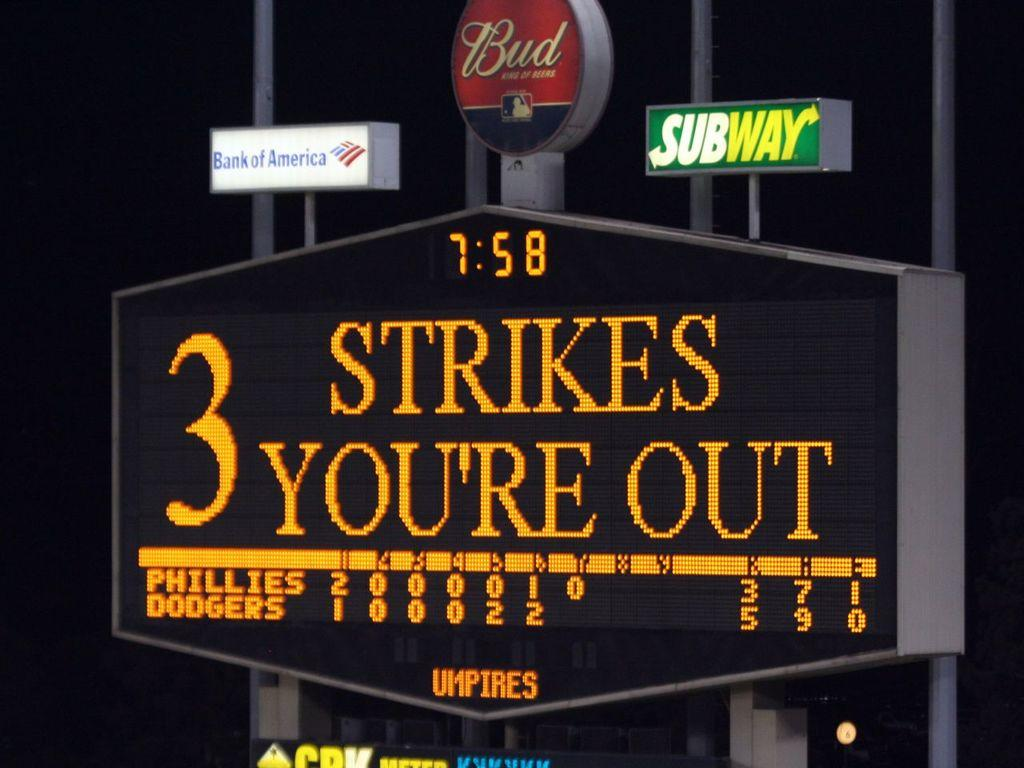<image>
Present a compact description of the photo's key features. A sign at a ballpark reading 3 strikes your out. 